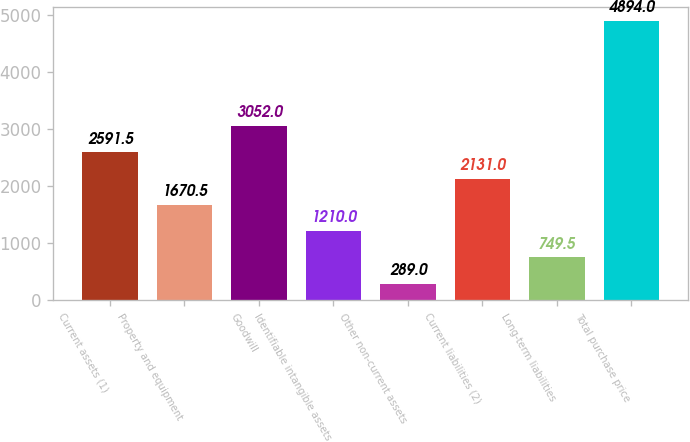Convert chart. <chart><loc_0><loc_0><loc_500><loc_500><bar_chart><fcel>Current assets (1)<fcel>Property and equipment<fcel>Goodwill<fcel>Identifiable intangible assets<fcel>Other non-current assets<fcel>Current liabilities (2)<fcel>Long-term liabilities<fcel>Total purchase price<nl><fcel>2591.5<fcel>1670.5<fcel>3052<fcel>1210<fcel>289<fcel>2131<fcel>749.5<fcel>4894<nl></chart> 